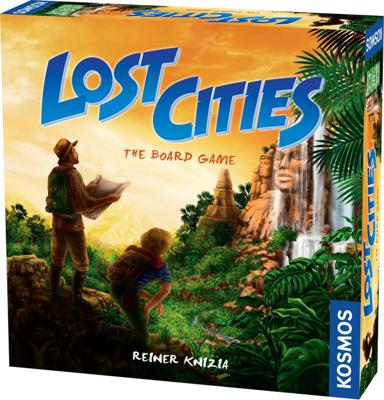What are the key visual elements on the game box that hint at its theme? The 'Lost Cities' game box is rich with visual elements that echo its adventure theme, featuring an image of explorers looking out over a lush, waterfall-strewn jungle landscape. There are hints of ancient ruins and exotic locales, suggesting the exploration and discovery aspects central to the game's theme. 